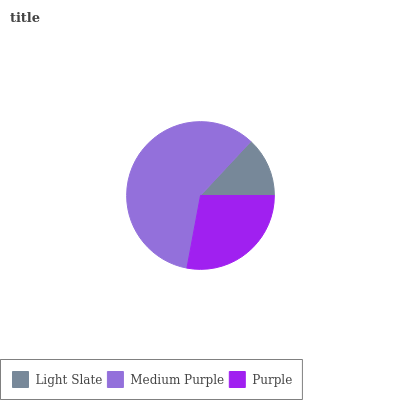Is Light Slate the minimum?
Answer yes or no. Yes. Is Medium Purple the maximum?
Answer yes or no. Yes. Is Purple the minimum?
Answer yes or no. No. Is Purple the maximum?
Answer yes or no. No. Is Medium Purple greater than Purple?
Answer yes or no. Yes. Is Purple less than Medium Purple?
Answer yes or no. Yes. Is Purple greater than Medium Purple?
Answer yes or no. No. Is Medium Purple less than Purple?
Answer yes or no. No. Is Purple the high median?
Answer yes or no. Yes. Is Purple the low median?
Answer yes or no. Yes. Is Light Slate the high median?
Answer yes or no. No. Is Light Slate the low median?
Answer yes or no. No. 